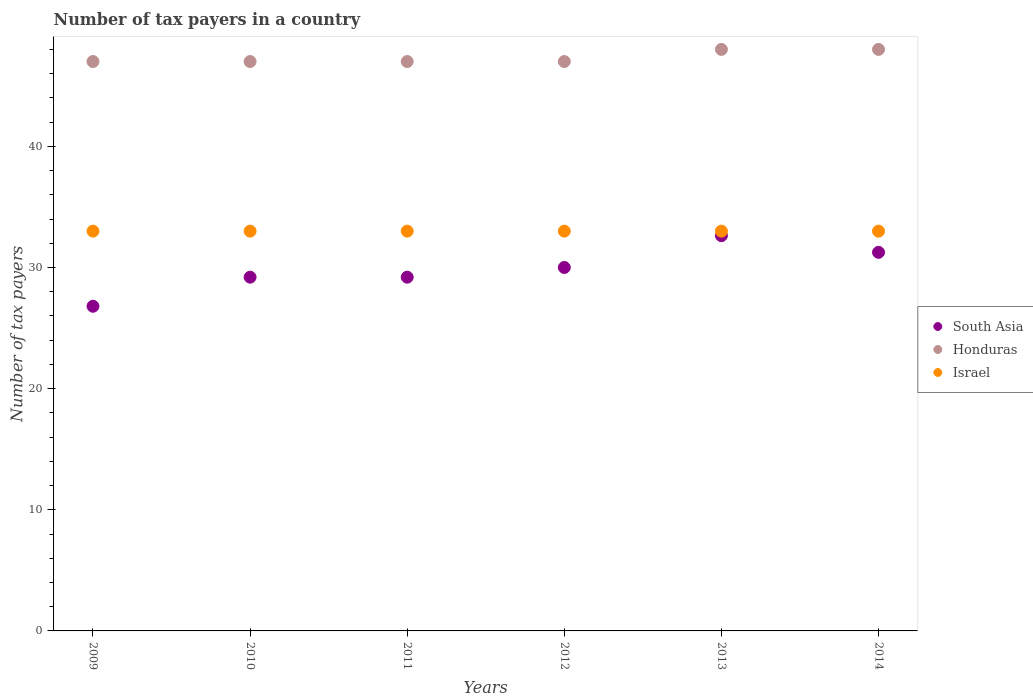How many different coloured dotlines are there?
Make the answer very short. 3. What is the number of tax payers in in Israel in 2012?
Your response must be concise. 33. Across all years, what is the maximum number of tax payers in in Israel?
Offer a terse response. 33. Across all years, what is the minimum number of tax payers in in South Asia?
Your answer should be compact. 26.8. In which year was the number of tax payers in in South Asia minimum?
Give a very brief answer. 2009. What is the total number of tax payers in in Israel in the graph?
Your answer should be compact. 198. What is the difference between the number of tax payers in in South Asia in 2010 and that in 2012?
Your response must be concise. -0.8. What is the difference between the number of tax payers in in South Asia in 2013 and the number of tax payers in in Honduras in 2014?
Provide a short and direct response. -15.38. What is the average number of tax payers in in Israel per year?
Provide a succinct answer. 33. In the year 2010, what is the difference between the number of tax payers in in South Asia and number of tax payers in in Israel?
Provide a short and direct response. -3.8. In how many years, is the number of tax payers in in Israel greater than 24?
Make the answer very short. 6. What is the ratio of the number of tax payers in in South Asia in 2011 to that in 2013?
Your answer should be very brief. 0.9. What is the difference between the highest and the second highest number of tax payers in in Honduras?
Give a very brief answer. 0. What is the difference between the highest and the lowest number of tax payers in in Honduras?
Provide a succinct answer. 1. Is it the case that in every year, the sum of the number of tax payers in in Israel and number of tax payers in in Honduras  is greater than the number of tax payers in in South Asia?
Offer a very short reply. Yes. Is the number of tax payers in in Honduras strictly greater than the number of tax payers in in Israel over the years?
Offer a very short reply. Yes. Is the number of tax payers in in South Asia strictly less than the number of tax payers in in Honduras over the years?
Provide a succinct answer. Yes. How many dotlines are there?
Make the answer very short. 3. How many years are there in the graph?
Provide a short and direct response. 6. What is the difference between two consecutive major ticks on the Y-axis?
Your answer should be compact. 10. Does the graph contain any zero values?
Your answer should be compact. No. Where does the legend appear in the graph?
Your answer should be very brief. Center right. What is the title of the graph?
Offer a terse response. Number of tax payers in a country. What is the label or title of the X-axis?
Keep it short and to the point. Years. What is the label or title of the Y-axis?
Offer a very short reply. Number of tax payers. What is the Number of tax payers of South Asia in 2009?
Your response must be concise. 26.8. What is the Number of tax payers of Israel in 2009?
Your response must be concise. 33. What is the Number of tax payers in South Asia in 2010?
Your answer should be very brief. 29.2. What is the Number of tax payers in Israel in 2010?
Your response must be concise. 33. What is the Number of tax payers of South Asia in 2011?
Keep it short and to the point. 29.2. What is the Number of tax payers in Honduras in 2011?
Offer a terse response. 47. What is the Number of tax payers in Israel in 2012?
Ensure brevity in your answer.  33. What is the Number of tax payers of South Asia in 2013?
Provide a succinct answer. 32.62. What is the Number of tax payers of Israel in 2013?
Ensure brevity in your answer.  33. What is the Number of tax payers of South Asia in 2014?
Your answer should be compact. 31.25. What is the Number of tax payers of Honduras in 2014?
Make the answer very short. 48. What is the Number of tax payers in Israel in 2014?
Your response must be concise. 33. Across all years, what is the maximum Number of tax payers of South Asia?
Your answer should be very brief. 32.62. Across all years, what is the minimum Number of tax payers of South Asia?
Provide a succinct answer. 26.8. Across all years, what is the minimum Number of tax payers of Honduras?
Your answer should be very brief. 47. Across all years, what is the minimum Number of tax payers of Israel?
Provide a short and direct response. 33. What is the total Number of tax payers in South Asia in the graph?
Keep it short and to the point. 179.07. What is the total Number of tax payers of Honduras in the graph?
Keep it short and to the point. 284. What is the total Number of tax payers of Israel in the graph?
Offer a very short reply. 198. What is the difference between the Number of tax payers in South Asia in 2009 and that in 2010?
Provide a short and direct response. -2.4. What is the difference between the Number of tax payers in Honduras in 2009 and that in 2011?
Your response must be concise. 0. What is the difference between the Number of tax payers in Israel in 2009 and that in 2011?
Offer a very short reply. 0. What is the difference between the Number of tax payers of South Asia in 2009 and that in 2012?
Make the answer very short. -3.2. What is the difference between the Number of tax payers in Honduras in 2009 and that in 2012?
Your response must be concise. 0. What is the difference between the Number of tax payers of South Asia in 2009 and that in 2013?
Offer a terse response. -5.83. What is the difference between the Number of tax payers in Honduras in 2009 and that in 2013?
Provide a short and direct response. -1. What is the difference between the Number of tax payers of South Asia in 2009 and that in 2014?
Your response must be concise. -4.45. What is the difference between the Number of tax payers in Honduras in 2009 and that in 2014?
Provide a short and direct response. -1. What is the difference between the Number of tax payers in Israel in 2009 and that in 2014?
Give a very brief answer. 0. What is the difference between the Number of tax payers in Honduras in 2010 and that in 2011?
Give a very brief answer. 0. What is the difference between the Number of tax payers of Israel in 2010 and that in 2011?
Offer a very short reply. 0. What is the difference between the Number of tax payers of Honduras in 2010 and that in 2012?
Offer a very short reply. 0. What is the difference between the Number of tax payers in Israel in 2010 and that in 2012?
Provide a succinct answer. 0. What is the difference between the Number of tax payers of South Asia in 2010 and that in 2013?
Make the answer very short. -3.42. What is the difference between the Number of tax payers in Honduras in 2010 and that in 2013?
Provide a succinct answer. -1. What is the difference between the Number of tax payers of Israel in 2010 and that in 2013?
Provide a succinct answer. 0. What is the difference between the Number of tax payers of South Asia in 2010 and that in 2014?
Give a very brief answer. -2.05. What is the difference between the Number of tax payers in Israel in 2010 and that in 2014?
Your response must be concise. 0. What is the difference between the Number of tax payers of South Asia in 2011 and that in 2012?
Provide a succinct answer. -0.8. What is the difference between the Number of tax payers of South Asia in 2011 and that in 2013?
Your response must be concise. -3.42. What is the difference between the Number of tax payers of Honduras in 2011 and that in 2013?
Offer a terse response. -1. What is the difference between the Number of tax payers of South Asia in 2011 and that in 2014?
Provide a succinct answer. -2.05. What is the difference between the Number of tax payers of South Asia in 2012 and that in 2013?
Provide a short and direct response. -2.62. What is the difference between the Number of tax payers of Israel in 2012 and that in 2013?
Your answer should be very brief. 0. What is the difference between the Number of tax payers in South Asia in 2012 and that in 2014?
Your answer should be very brief. -1.25. What is the difference between the Number of tax payers of Honduras in 2012 and that in 2014?
Your response must be concise. -1. What is the difference between the Number of tax payers of South Asia in 2013 and that in 2014?
Ensure brevity in your answer.  1.38. What is the difference between the Number of tax payers in Honduras in 2013 and that in 2014?
Keep it short and to the point. 0. What is the difference between the Number of tax payers in Israel in 2013 and that in 2014?
Provide a succinct answer. 0. What is the difference between the Number of tax payers in South Asia in 2009 and the Number of tax payers in Honduras in 2010?
Ensure brevity in your answer.  -20.2. What is the difference between the Number of tax payers in South Asia in 2009 and the Number of tax payers in Israel in 2010?
Make the answer very short. -6.2. What is the difference between the Number of tax payers of South Asia in 2009 and the Number of tax payers of Honduras in 2011?
Make the answer very short. -20.2. What is the difference between the Number of tax payers in Honduras in 2009 and the Number of tax payers in Israel in 2011?
Ensure brevity in your answer.  14. What is the difference between the Number of tax payers in South Asia in 2009 and the Number of tax payers in Honduras in 2012?
Provide a short and direct response. -20.2. What is the difference between the Number of tax payers in South Asia in 2009 and the Number of tax payers in Honduras in 2013?
Give a very brief answer. -21.2. What is the difference between the Number of tax payers in South Asia in 2009 and the Number of tax payers in Israel in 2013?
Provide a succinct answer. -6.2. What is the difference between the Number of tax payers in Honduras in 2009 and the Number of tax payers in Israel in 2013?
Make the answer very short. 14. What is the difference between the Number of tax payers in South Asia in 2009 and the Number of tax payers in Honduras in 2014?
Offer a very short reply. -21.2. What is the difference between the Number of tax payers of South Asia in 2010 and the Number of tax payers of Honduras in 2011?
Offer a very short reply. -17.8. What is the difference between the Number of tax payers of Honduras in 2010 and the Number of tax payers of Israel in 2011?
Provide a succinct answer. 14. What is the difference between the Number of tax payers in South Asia in 2010 and the Number of tax payers in Honduras in 2012?
Make the answer very short. -17.8. What is the difference between the Number of tax payers of South Asia in 2010 and the Number of tax payers of Israel in 2012?
Provide a succinct answer. -3.8. What is the difference between the Number of tax payers of South Asia in 2010 and the Number of tax payers of Honduras in 2013?
Keep it short and to the point. -18.8. What is the difference between the Number of tax payers in South Asia in 2010 and the Number of tax payers in Israel in 2013?
Your response must be concise. -3.8. What is the difference between the Number of tax payers in Honduras in 2010 and the Number of tax payers in Israel in 2013?
Keep it short and to the point. 14. What is the difference between the Number of tax payers in South Asia in 2010 and the Number of tax payers in Honduras in 2014?
Give a very brief answer. -18.8. What is the difference between the Number of tax payers of South Asia in 2011 and the Number of tax payers of Honduras in 2012?
Keep it short and to the point. -17.8. What is the difference between the Number of tax payers in South Asia in 2011 and the Number of tax payers in Israel in 2012?
Your answer should be very brief. -3.8. What is the difference between the Number of tax payers in South Asia in 2011 and the Number of tax payers in Honduras in 2013?
Give a very brief answer. -18.8. What is the difference between the Number of tax payers of South Asia in 2011 and the Number of tax payers of Israel in 2013?
Ensure brevity in your answer.  -3.8. What is the difference between the Number of tax payers in Honduras in 2011 and the Number of tax payers in Israel in 2013?
Provide a succinct answer. 14. What is the difference between the Number of tax payers of South Asia in 2011 and the Number of tax payers of Honduras in 2014?
Your answer should be compact. -18.8. What is the difference between the Number of tax payers of South Asia in 2011 and the Number of tax payers of Israel in 2014?
Your response must be concise. -3.8. What is the difference between the Number of tax payers of South Asia in 2012 and the Number of tax payers of Honduras in 2013?
Keep it short and to the point. -18. What is the difference between the Number of tax payers in Honduras in 2012 and the Number of tax payers in Israel in 2013?
Provide a short and direct response. 14. What is the difference between the Number of tax payers of South Asia in 2013 and the Number of tax payers of Honduras in 2014?
Your response must be concise. -15.38. What is the difference between the Number of tax payers of South Asia in 2013 and the Number of tax payers of Israel in 2014?
Offer a very short reply. -0.38. What is the difference between the Number of tax payers of Honduras in 2013 and the Number of tax payers of Israel in 2014?
Ensure brevity in your answer.  15. What is the average Number of tax payers of South Asia per year?
Your answer should be very brief. 29.85. What is the average Number of tax payers in Honduras per year?
Keep it short and to the point. 47.33. What is the average Number of tax payers in Israel per year?
Ensure brevity in your answer.  33. In the year 2009, what is the difference between the Number of tax payers of South Asia and Number of tax payers of Honduras?
Give a very brief answer. -20.2. In the year 2009, what is the difference between the Number of tax payers in South Asia and Number of tax payers in Israel?
Offer a very short reply. -6.2. In the year 2009, what is the difference between the Number of tax payers in Honduras and Number of tax payers in Israel?
Keep it short and to the point. 14. In the year 2010, what is the difference between the Number of tax payers of South Asia and Number of tax payers of Honduras?
Keep it short and to the point. -17.8. In the year 2010, what is the difference between the Number of tax payers of South Asia and Number of tax payers of Israel?
Keep it short and to the point. -3.8. In the year 2010, what is the difference between the Number of tax payers in Honduras and Number of tax payers in Israel?
Provide a short and direct response. 14. In the year 2011, what is the difference between the Number of tax payers in South Asia and Number of tax payers in Honduras?
Give a very brief answer. -17.8. In the year 2011, what is the difference between the Number of tax payers in South Asia and Number of tax payers in Israel?
Provide a short and direct response. -3.8. In the year 2012, what is the difference between the Number of tax payers in South Asia and Number of tax payers in Honduras?
Your response must be concise. -17. In the year 2012, what is the difference between the Number of tax payers in South Asia and Number of tax payers in Israel?
Ensure brevity in your answer.  -3. In the year 2012, what is the difference between the Number of tax payers of Honduras and Number of tax payers of Israel?
Offer a terse response. 14. In the year 2013, what is the difference between the Number of tax payers of South Asia and Number of tax payers of Honduras?
Give a very brief answer. -15.38. In the year 2013, what is the difference between the Number of tax payers of South Asia and Number of tax payers of Israel?
Offer a terse response. -0.38. In the year 2014, what is the difference between the Number of tax payers in South Asia and Number of tax payers in Honduras?
Offer a terse response. -16.75. In the year 2014, what is the difference between the Number of tax payers in South Asia and Number of tax payers in Israel?
Your response must be concise. -1.75. In the year 2014, what is the difference between the Number of tax payers of Honduras and Number of tax payers of Israel?
Offer a terse response. 15. What is the ratio of the Number of tax payers of South Asia in 2009 to that in 2010?
Offer a very short reply. 0.92. What is the ratio of the Number of tax payers of Honduras in 2009 to that in 2010?
Make the answer very short. 1. What is the ratio of the Number of tax payers of South Asia in 2009 to that in 2011?
Ensure brevity in your answer.  0.92. What is the ratio of the Number of tax payers of South Asia in 2009 to that in 2012?
Provide a succinct answer. 0.89. What is the ratio of the Number of tax payers in Honduras in 2009 to that in 2012?
Provide a short and direct response. 1. What is the ratio of the Number of tax payers in Israel in 2009 to that in 2012?
Provide a succinct answer. 1. What is the ratio of the Number of tax payers in South Asia in 2009 to that in 2013?
Provide a short and direct response. 0.82. What is the ratio of the Number of tax payers of Honduras in 2009 to that in 2013?
Your answer should be very brief. 0.98. What is the ratio of the Number of tax payers in Israel in 2009 to that in 2013?
Your answer should be very brief. 1. What is the ratio of the Number of tax payers of South Asia in 2009 to that in 2014?
Offer a terse response. 0.86. What is the ratio of the Number of tax payers of Honduras in 2009 to that in 2014?
Your answer should be very brief. 0.98. What is the ratio of the Number of tax payers in Israel in 2009 to that in 2014?
Offer a very short reply. 1. What is the ratio of the Number of tax payers of South Asia in 2010 to that in 2011?
Offer a very short reply. 1. What is the ratio of the Number of tax payers of Honduras in 2010 to that in 2011?
Your response must be concise. 1. What is the ratio of the Number of tax payers of Israel in 2010 to that in 2011?
Provide a succinct answer. 1. What is the ratio of the Number of tax payers in South Asia in 2010 to that in 2012?
Make the answer very short. 0.97. What is the ratio of the Number of tax payers of Israel in 2010 to that in 2012?
Ensure brevity in your answer.  1. What is the ratio of the Number of tax payers in South Asia in 2010 to that in 2013?
Your answer should be very brief. 0.9. What is the ratio of the Number of tax payers of Honduras in 2010 to that in 2013?
Your response must be concise. 0.98. What is the ratio of the Number of tax payers in Israel in 2010 to that in 2013?
Provide a succinct answer. 1. What is the ratio of the Number of tax payers of South Asia in 2010 to that in 2014?
Your answer should be compact. 0.93. What is the ratio of the Number of tax payers of Honduras in 2010 to that in 2014?
Ensure brevity in your answer.  0.98. What is the ratio of the Number of tax payers in Israel in 2010 to that in 2014?
Make the answer very short. 1. What is the ratio of the Number of tax payers in South Asia in 2011 to that in 2012?
Your answer should be very brief. 0.97. What is the ratio of the Number of tax payers in Honduras in 2011 to that in 2012?
Your answer should be compact. 1. What is the ratio of the Number of tax payers in Israel in 2011 to that in 2012?
Your response must be concise. 1. What is the ratio of the Number of tax payers in South Asia in 2011 to that in 2013?
Your response must be concise. 0.9. What is the ratio of the Number of tax payers in Honduras in 2011 to that in 2013?
Give a very brief answer. 0.98. What is the ratio of the Number of tax payers of Israel in 2011 to that in 2013?
Keep it short and to the point. 1. What is the ratio of the Number of tax payers of South Asia in 2011 to that in 2014?
Your answer should be very brief. 0.93. What is the ratio of the Number of tax payers of Honduras in 2011 to that in 2014?
Make the answer very short. 0.98. What is the ratio of the Number of tax payers of South Asia in 2012 to that in 2013?
Your answer should be compact. 0.92. What is the ratio of the Number of tax payers in Honduras in 2012 to that in 2013?
Keep it short and to the point. 0.98. What is the ratio of the Number of tax payers in Honduras in 2012 to that in 2014?
Your answer should be very brief. 0.98. What is the ratio of the Number of tax payers in South Asia in 2013 to that in 2014?
Give a very brief answer. 1.04. What is the difference between the highest and the second highest Number of tax payers of South Asia?
Give a very brief answer. 1.38. What is the difference between the highest and the second highest Number of tax payers in Honduras?
Your answer should be compact. 0. What is the difference between the highest and the second highest Number of tax payers in Israel?
Ensure brevity in your answer.  0. What is the difference between the highest and the lowest Number of tax payers in South Asia?
Keep it short and to the point. 5.83. What is the difference between the highest and the lowest Number of tax payers in Israel?
Ensure brevity in your answer.  0. 